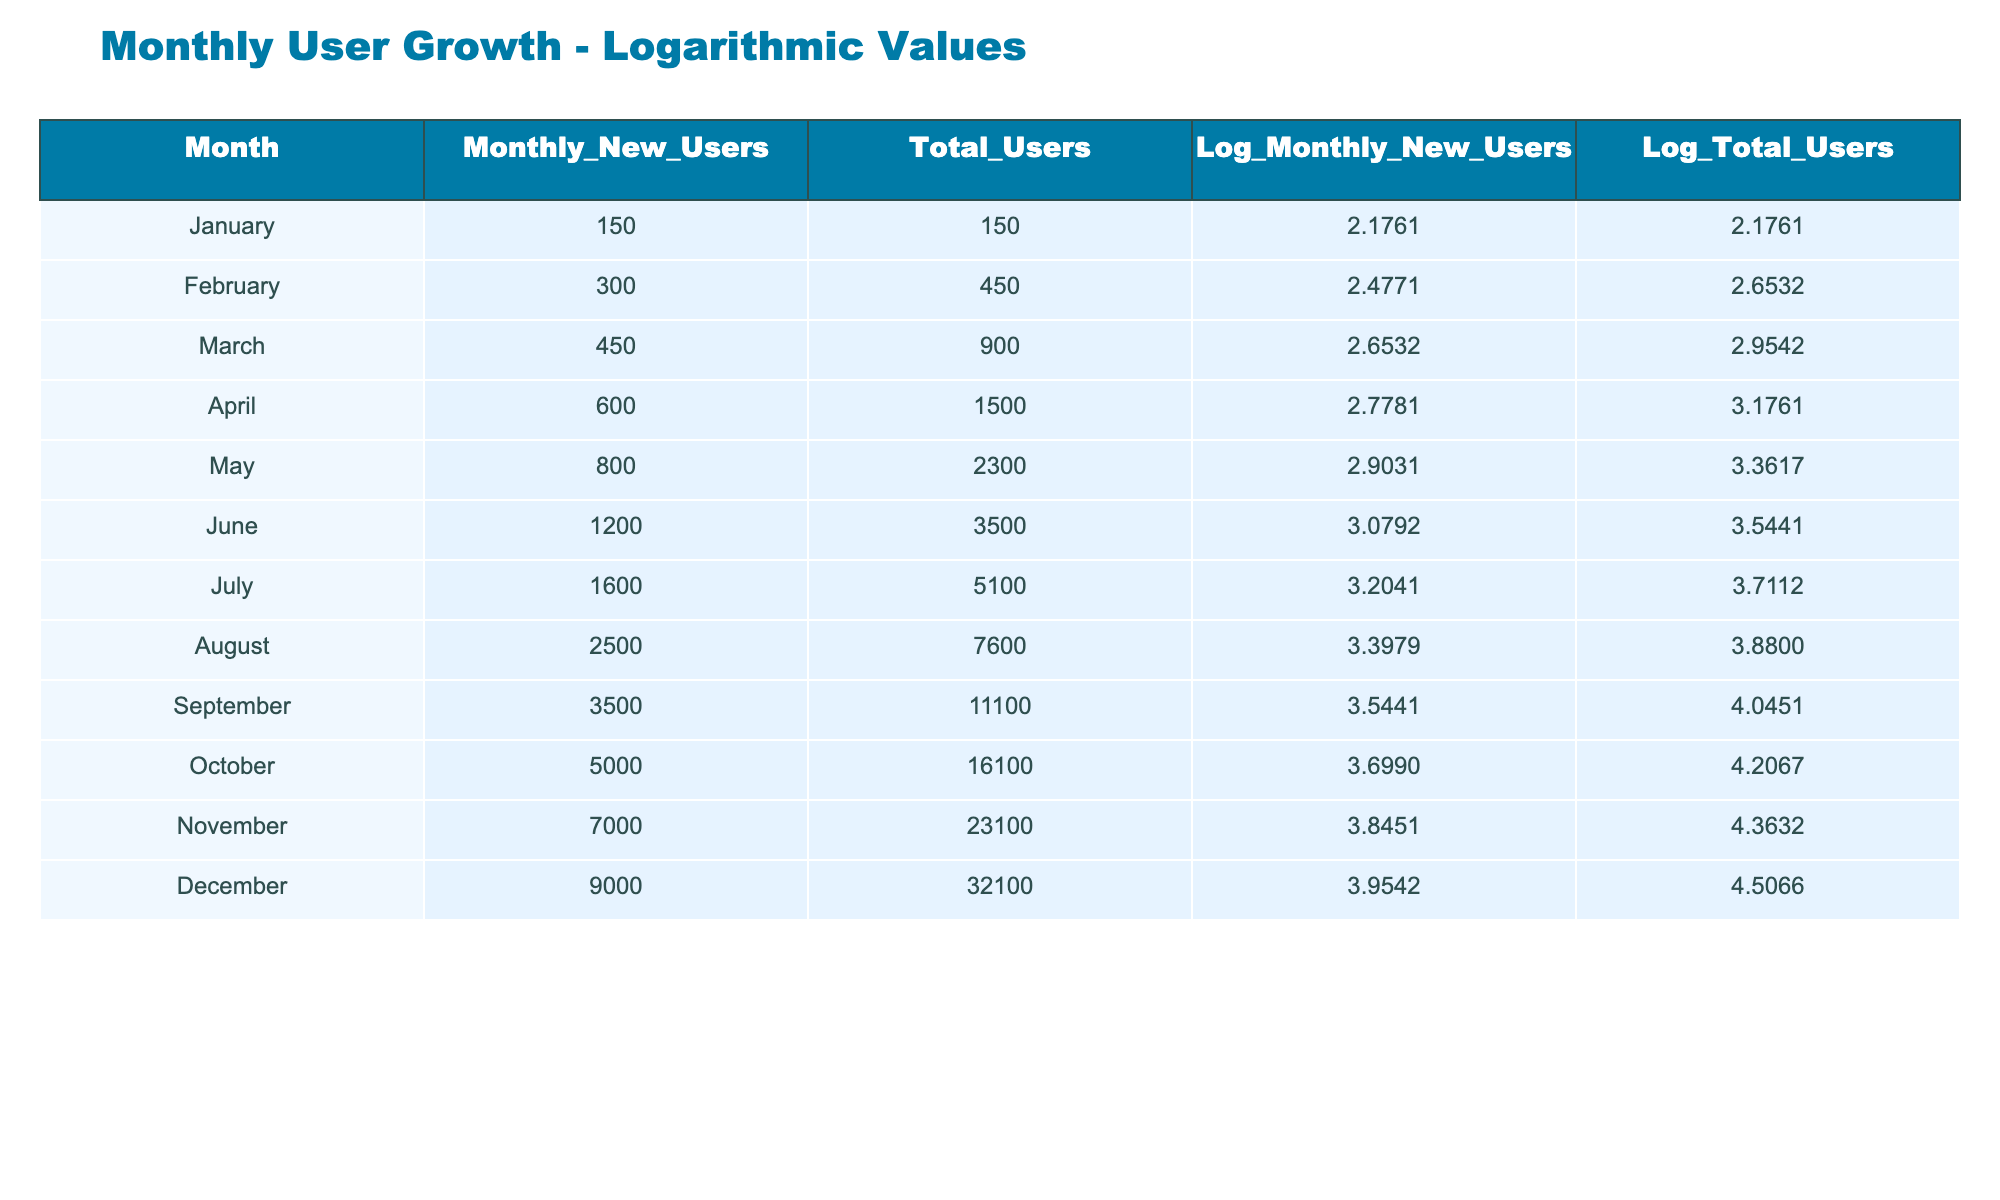What was the total number of users in March? From the table, the total number of users in March is listed in the column "Total_Users" for that month, which is 900.
Answer: 900 What is the logarithmic value of monthly new users in August? The logarithmic value for monthly new users is recorded in the column "Log_Monthly_New_Users" for August, which is 3.3979.
Answer: 3.3979 Did the number of monthly new users in October exceed 4000? Looking at the column "Monthly_New_Users" for October, it shows 5000, which is greater than 4000. Therefore, the statement is true.
Answer: Yes What is the average number of new users from January to June? To find the average, we add up the monthly new users: 150 + 300 + 450 + 600 + 800 + 1200 = 2500. Then, dividing by 6 gives us 2500 / 6 = 416.67.
Answer: Approximately 416.67 Which month had the highest total users and what was that value? The month with the highest total users is December, with a total recorded in the "Total_Users" column, which is 32100.
Answer: 32100 What was the increase in total users from February to March? For February, total users are 450 and for March, it is 900. The increase is calculated as 900 - 450 = 450.
Answer: 450 Is the logarithmic value of total users in November higher than in September? The logarithmic values for November and September are 4.3632 and 4.0451, respectively. Since 4.3632 is greater than 4.0451, the statement is true.
Answer: Yes What is the difference in the logarithmic values of total users between April and June? The logarithmic value of total users in April is 3.1761 and in June it is 3.5441. The difference is 3.5441 - 3.1761 = 0.3680.
Answer: 0.3680 How many new users were added from July to August? In July, the monthly new users were 1600, and in August, they were 2500. The increase is 2500 - 1600 = 900 new users.
Answer: 900 